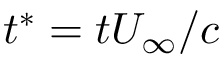<formula> <loc_0><loc_0><loc_500><loc_500>t ^ { * } = t U _ { \infty } / c</formula> 